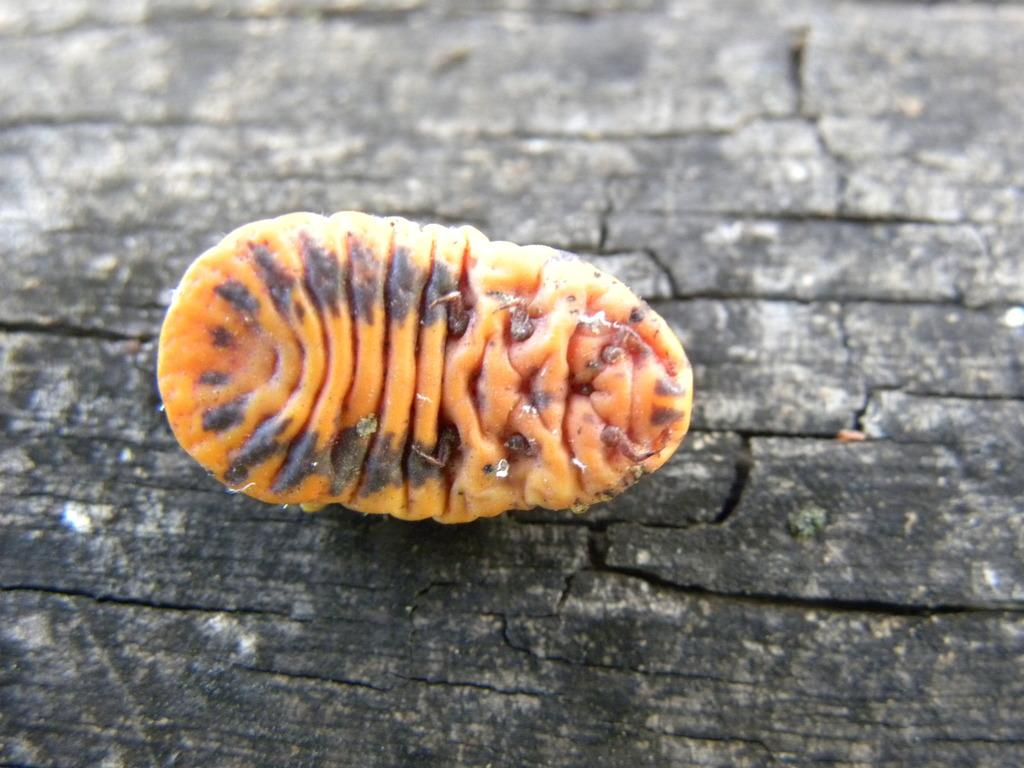What is the main subject of the picture? The main subject of the picture is an insect. Can you describe the color of the insect? The insect is yellow in color. Where is the insect located in the picture? The insect is in the middle of the picture. What is the background or surface the insect is on? The insect is on a black surface. What theory does the toad in the image propose? There is no toad present in the image, so it cannot propose any theories. 